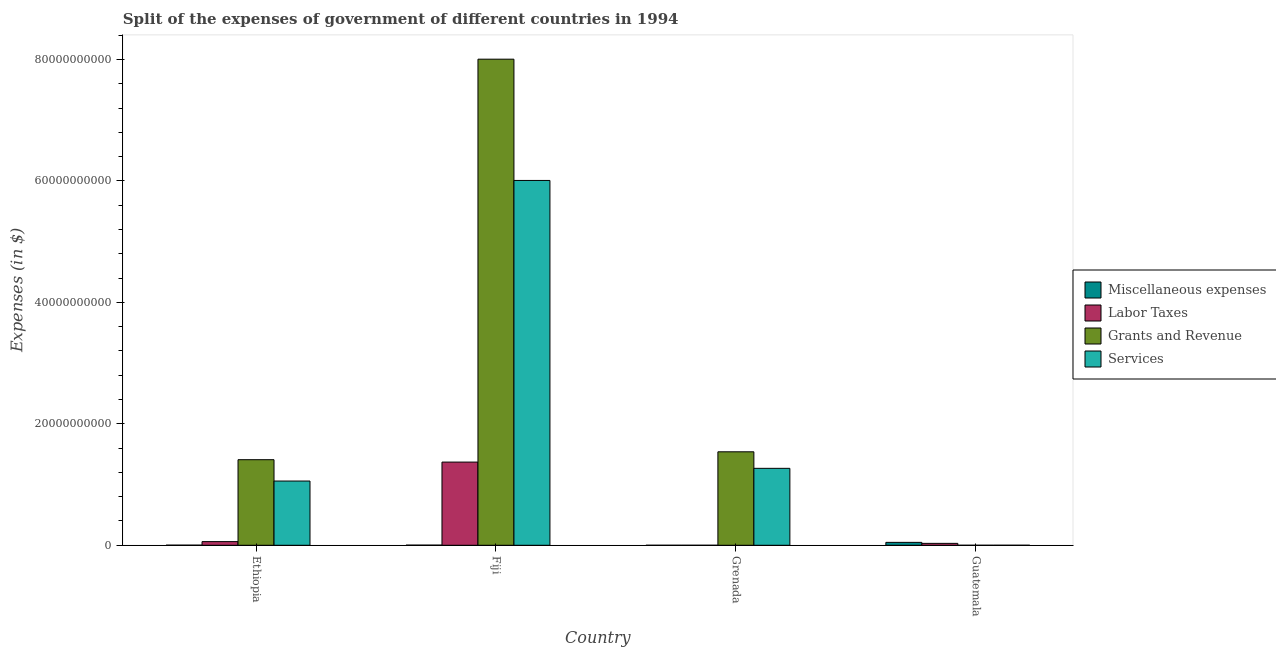Are the number of bars per tick equal to the number of legend labels?
Offer a terse response. Yes. How many bars are there on the 1st tick from the left?
Provide a succinct answer. 4. What is the label of the 1st group of bars from the left?
Provide a succinct answer. Ethiopia. What is the amount spent on grants and revenue in Fiji?
Offer a terse response. 8.00e+1. Across all countries, what is the maximum amount spent on grants and revenue?
Provide a short and direct response. 8.00e+1. Across all countries, what is the minimum amount spent on labor taxes?
Make the answer very short. 1.07e+05. In which country was the amount spent on labor taxes maximum?
Provide a short and direct response. Fiji. In which country was the amount spent on miscellaneous expenses minimum?
Provide a short and direct response. Grenada. What is the total amount spent on labor taxes in the graph?
Give a very brief answer. 1.46e+1. What is the difference between the amount spent on labor taxes in Fiji and that in Guatemala?
Your answer should be very brief. 1.34e+1. What is the difference between the amount spent on services in Ethiopia and the amount spent on miscellaneous expenses in Guatemala?
Make the answer very short. 1.01e+1. What is the average amount spent on grants and revenue per country?
Your answer should be very brief. 2.74e+1. What is the difference between the amount spent on miscellaneous expenses and amount spent on grants and revenue in Grenada?
Your response must be concise. -1.54e+1. In how many countries, is the amount spent on labor taxes greater than 8000000000 $?
Give a very brief answer. 1. What is the ratio of the amount spent on labor taxes in Ethiopia to that in Grenada?
Your response must be concise. 5616.09. Is the amount spent on services in Ethiopia less than that in Grenada?
Offer a terse response. Yes. What is the difference between the highest and the second highest amount spent on grants and revenue?
Offer a terse response. 6.47e+1. What is the difference between the highest and the lowest amount spent on services?
Provide a short and direct response. 6.01e+1. In how many countries, is the amount spent on miscellaneous expenses greater than the average amount spent on miscellaneous expenses taken over all countries?
Your response must be concise. 1. Is it the case that in every country, the sum of the amount spent on grants and revenue and amount spent on services is greater than the sum of amount spent on labor taxes and amount spent on miscellaneous expenses?
Ensure brevity in your answer.  No. What does the 4th bar from the left in Grenada represents?
Give a very brief answer. Services. What does the 1st bar from the right in Ethiopia represents?
Ensure brevity in your answer.  Services. Are all the bars in the graph horizontal?
Your answer should be compact. No. How many countries are there in the graph?
Your answer should be compact. 4. What is the difference between two consecutive major ticks on the Y-axis?
Make the answer very short. 2.00e+1. Are the values on the major ticks of Y-axis written in scientific E-notation?
Make the answer very short. No. Does the graph contain any zero values?
Provide a short and direct response. No. Does the graph contain grids?
Keep it short and to the point. No. How are the legend labels stacked?
Your answer should be very brief. Vertical. What is the title of the graph?
Offer a terse response. Split of the expenses of government of different countries in 1994. What is the label or title of the Y-axis?
Provide a short and direct response. Expenses (in $). What is the Expenses (in $) of Miscellaneous expenses in Ethiopia?
Your response must be concise. 1.81e+07. What is the Expenses (in $) of Labor Taxes in Ethiopia?
Your response must be concise. 6.03e+08. What is the Expenses (in $) in Grants and Revenue in Ethiopia?
Your answer should be very brief. 1.41e+1. What is the Expenses (in $) of Services in Ethiopia?
Offer a very short reply. 1.06e+1. What is the Expenses (in $) of Miscellaneous expenses in Fiji?
Make the answer very short. 2.37e+07. What is the Expenses (in $) of Labor Taxes in Fiji?
Make the answer very short. 1.37e+1. What is the Expenses (in $) in Grants and Revenue in Fiji?
Make the answer very short. 8.00e+1. What is the Expenses (in $) in Services in Fiji?
Give a very brief answer. 6.01e+1. What is the Expenses (in $) of Miscellaneous expenses in Grenada?
Give a very brief answer. 1.17e+06. What is the Expenses (in $) in Labor Taxes in Grenada?
Your response must be concise. 1.07e+05. What is the Expenses (in $) of Grants and Revenue in Grenada?
Provide a succinct answer. 1.54e+1. What is the Expenses (in $) of Services in Grenada?
Offer a very short reply. 1.27e+1. What is the Expenses (in $) of Miscellaneous expenses in Guatemala?
Provide a short and direct response. 4.79e+08. What is the Expenses (in $) of Labor Taxes in Guatemala?
Your response must be concise. 3.14e+08. What is the Expenses (in $) of Grants and Revenue in Guatemala?
Your answer should be very brief. 4.09e+05. What is the Expenses (in $) in Services in Guatemala?
Offer a very short reply. 1.49e+06. Across all countries, what is the maximum Expenses (in $) in Miscellaneous expenses?
Ensure brevity in your answer.  4.79e+08. Across all countries, what is the maximum Expenses (in $) in Labor Taxes?
Keep it short and to the point. 1.37e+1. Across all countries, what is the maximum Expenses (in $) in Grants and Revenue?
Offer a terse response. 8.00e+1. Across all countries, what is the maximum Expenses (in $) of Services?
Provide a succinct answer. 6.01e+1. Across all countries, what is the minimum Expenses (in $) of Miscellaneous expenses?
Your answer should be compact. 1.17e+06. Across all countries, what is the minimum Expenses (in $) of Labor Taxes?
Keep it short and to the point. 1.07e+05. Across all countries, what is the minimum Expenses (in $) in Grants and Revenue?
Keep it short and to the point. 4.09e+05. Across all countries, what is the minimum Expenses (in $) in Services?
Ensure brevity in your answer.  1.49e+06. What is the total Expenses (in $) of Miscellaneous expenses in the graph?
Keep it short and to the point. 5.22e+08. What is the total Expenses (in $) of Labor Taxes in the graph?
Provide a short and direct response. 1.46e+1. What is the total Expenses (in $) of Grants and Revenue in the graph?
Offer a very short reply. 1.10e+11. What is the total Expenses (in $) of Services in the graph?
Provide a succinct answer. 8.33e+1. What is the difference between the Expenses (in $) of Miscellaneous expenses in Ethiopia and that in Fiji?
Ensure brevity in your answer.  -5.62e+06. What is the difference between the Expenses (in $) in Labor Taxes in Ethiopia and that in Fiji?
Keep it short and to the point. -1.31e+1. What is the difference between the Expenses (in $) of Grants and Revenue in Ethiopia and that in Fiji?
Your answer should be very brief. -6.60e+1. What is the difference between the Expenses (in $) in Services in Ethiopia and that in Fiji?
Your answer should be compact. -4.95e+1. What is the difference between the Expenses (in $) of Miscellaneous expenses in Ethiopia and that in Grenada?
Offer a terse response. 1.69e+07. What is the difference between the Expenses (in $) in Labor Taxes in Ethiopia and that in Grenada?
Keep it short and to the point. 6.03e+08. What is the difference between the Expenses (in $) in Grants and Revenue in Ethiopia and that in Grenada?
Ensure brevity in your answer.  -1.30e+09. What is the difference between the Expenses (in $) of Services in Ethiopia and that in Grenada?
Offer a terse response. -2.09e+09. What is the difference between the Expenses (in $) in Miscellaneous expenses in Ethiopia and that in Guatemala?
Offer a terse response. -4.61e+08. What is the difference between the Expenses (in $) of Labor Taxes in Ethiopia and that in Guatemala?
Give a very brief answer. 2.89e+08. What is the difference between the Expenses (in $) of Grants and Revenue in Ethiopia and that in Guatemala?
Your answer should be compact. 1.41e+1. What is the difference between the Expenses (in $) of Services in Ethiopia and that in Guatemala?
Give a very brief answer. 1.06e+1. What is the difference between the Expenses (in $) of Miscellaneous expenses in Fiji and that in Grenada?
Your answer should be compact. 2.26e+07. What is the difference between the Expenses (in $) of Labor Taxes in Fiji and that in Grenada?
Keep it short and to the point. 1.37e+1. What is the difference between the Expenses (in $) in Grants and Revenue in Fiji and that in Grenada?
Offer a very short reply. 6.47e+1. What is the difference between the Expenses (in $) of Services in Fiji and that in Grenada?
Offer a terse response. 4.74e+1. What is the difference between the Expenses (in $) in Miscellaneous expenses in Fiji and that in Guatemala?
Provide a short and direct response. -4.55e+08. What is the difference between the Expenses (in $) in Labor Taxes in Fiji and that in Guatemala?
Give a very brief answer. 1.34e+1. What is the difference between the Expenses (in $) of Grants and Revenue in Fiji and that in Guatemala?
Offer a terse response. 8.00e+1. What is the difference between the Expenses (in $) in Services in Fiji and that in Guatemala?
Offer a terse response. 6.01e+1. What is the difference between the Expenses (in $) of Miscellaneous expenses in Grenada and that in Guatemala?
Your answer should be very brief. -4.78e+08. What is the difference between the Expenses (in $) in Labor Taxes in Grenada and that in Guatemala?
Ensure brevity in your answer.  -3.13e+08. What is the difference between the Expenses (in $) of Grants and Revenue in Grenada and that in Guatemala?
Your answer should be very brief. 1.54e+1. What is the difference between the Expenses (in $) of Services in Grenada and that in Guatemala?
Offer a terse response. 1.27e+1. What is the difference between the Expenses (in $) in Miscellaneous expenses in Ethiopia and the Expenses (in $) in Labor Taxes in Fiji?
Your response must be concise. -1.37e+1. What is the difference between the Expenses (in $) in Miscellaneous expenses in Ethiopia and the Expenses (in $) in Grants and Revenue in Fiji?
Give a very brief answer. -8.00e+1. What is the difference between the Expenses (in $) in Miscellaneous expenses in Ethiopia and the Expenses (in $) in Services in Fiji?
Offer a terse response. -6.01e+1. What is the difference between the Expenses (in $) of Labor Taxes in Ethiopia and the Expenses (in $) of Grants and Revenue in Fiji?
Keep it short and to the point. -7.94e+1. What is the difference between the Expenses (in $) in Labor Taxes in Ethiopia and the Expenses (in $) in Services in Fiji?
Provide a succinct answer. -5.95e+1. What is the difference between the Expenses (in $) of Grants and Revenue in Ethiopia and the Expenses (in $) of Services in Fiji?
Offer a terse response. -4.60e+1. What is the difference between the Expenses (in $) of Miscellaneous expenses in Ethiopia and the Expenses (in $) of Labor Taxes in Grenada?
Make the answer very short. 1.80e+07. What is the difference between the Expenses (in $) in Miscellaneous expenses in Ethiopia and the Expenses (in $) in Grants and Revenue in Grenada?
Provide a short and direct response. -1.54e+1. What is the difference between the Expenses (in $) of Miscellaneous expenses in Ethiopia and the Expenses (in $) of Services in Grenada?
Your response must be concise. -1.27e+1. What is the difference between the Expenses (in $) in Labor Taxes in Ethiopia and the Expenses (in $) in Grants and Revenue in Grenada?
Provide a short and direct response. -1.48e+1. What is the difference between the Expenses (in $) of Labor Taxes in Ethiopia and the Expenses (in $) of Services in Grenada?
Make the answer very short. -1.21e+1. What is the difference between the Expenses (in $) of Grants and Revenue in Ethiopia and the Expenses (in $) of Services in Grenada?
Make the answer very short. 1.42e+09. What is the difference between the Expenses (in $) in Miscellaneous expenses in Ethiopia and the Expenses (in $) in Labor Taxes in Guatemala?
Make the answer very short. -2.95e+08. What is the difference between the Expenses (in $) of Miscellaneous expenses in Ethiopia and the Expenses (in $) of Grants and Revenue in Guatemala?
Give a very brief answer. 1.77e+07. What is the difference between the Expenses (in $) in Miscellaneous expenses in Ethiopia and the Expenses (in $) in Services in Guatemala?
Keep it short and to the point. 1.66e+07. What is the difference between the Expenses (in $) of Labor Taxes in Ethiopia and the Expenses (in $) of Grants and Revenue in Guatemala?
Make the answer very short. 6.03e+08. What is the difference between the Expenses (in $) of Labor Taxes in Ethiopia and the Expenses (in $) of Services in Guatemala?
Ensure brevity in your answer.  6.02e+08. What is the difference between the Expenses (in $) in Grants and Revenue in Ethiopia and the Expenses (in $) in Services in Guatemala?
Offer a very short reply. 1.41e+1. What is the difference between the Expenses (in $) in Miscellaneous expenses in Fiji and the Expenses (in $) in Labor Taxes in Grenada?
Offer a terse response. 2.36e+07. What is the difference between the Expenses (in $) in Miscellaneous expenses in Fiji and the Expenses (in $) in Grants and Revenue in Grenada?
Provide a short and direct response. -1.54e+1. What is the difference between the Expenses (in $) of Miscellaneous expenses in Fiji and the Expenses (in $) of Services in Grenada?
Make the answer very short. -1.26e+1. What is the difference between the Expenses (in $) in Labor Taxes in Fiji and the Expenses (in $) in Grants and Revenue in Grenada?
Your response must be concise. -1.69e+09. What is the difference between the Expenses (in $) of Labor Taxes in Fiji and the Expenses (in $) of Services in Grenada?
Keep it short and to the point. 1.03e+09. What is the difference between the Expenses (in $) in Grants and Revenue in Fiji and the Expenses (in $) in Services in Grenada?
Your answer should be very brief. 6.74e+1. What is the difference between the Expenses (in $) of Miscellaneous expenses in Fiji and the Expenses (in $) of Labor Taxes in Guatemala?
Your answer should be compact. -2.90e+08. What is the difference between the Expenses (in $) of Miscellaneous expenses in Fiji and the Expenses (in $) of Grants and Revenue in Guatemala?
Make the answer very short. 2.33e+07. What is the difference between the Expenses (in $) of Miscellaneous expenses in Fiji and the Expenses (in $) of Services in Guatemala?
Give a very brief answer. 2.22e+07. What is the difference between the Expenses (in $) in Labor Taxes in Fiji and the Expenses (in $) in Grants and Revenue in Guatemala?
Ensure brevity in your answer.  1.37e+1. What is the difference between the Expenses (in $) in Labor Taxes in Fiji and the Expenses (in $) in Services in Guatemala?
Provide a succinct answer. 1.37e+1. What is the difference between the Expenses (in $) of Grants and Revenue in Fiji and the Expenses (in $) of Services in Guatemala?
Make the answer very short. 8.00e+1. What is the difference between the Expenses (in $) of Miscellaneous expenses in Grenada and the Expenses (in $) of Labor Taxes in Guatemala?
Your answer should be compact. -3.12e+08. What is the difference between the Expenses (in $) in Miscellaneous expenses in Grenada and the Expenses (in $) in Grants and Revenue in Guatemala?
Ensure brevity in your answer.  7.61e+05. What is the difference between the Expenses (in $) in Miscellaneous expenses in Grenada and the Expenses (in $) in Services in Guatemala?
Provide a short and direct response. -3.23e+05. What is the difference between the Expenses (in $) of Labor Taxes in Grenada and the Expenses (in $) of Grants and Revenue in Guatemala?
Your response must be concise. -3.02e+05. What is the difference between the Expenses (in $) of Labor Taxes in Grenada and the Expenses (in $) of Services in Guatemala?
Provide a succinct answer. -1.39e+06. What is the difference between the Expenses (in $) in Grants and Revenue in Grenada and the Expenses (in $) in Services in Guatemala?
Make the answer very short. 1.54e+1. What is the average Expenses (in $) in Miscellaneous expenses per country?
Give a very brief answer. 1.31e+08. What is the average Expenses (in $) in Labor Taxes per country?
Offer a terse response. 3.65e+09. What is the average Expenses (in $) of Grants and Revenue per country?
Your answer should be compact. 2.74e+1. What is the average Expenses (in $) of Services per country?
Provide a succinct answer. 2.08e+1. What is the difference between the Expenses (in $) in Miscellaneous expenses and Expenses (in $) in Labor Taxes in Ethiopia?
Provide a short and direct response. -5.85e+08. What is the difference between the Expenses (in $) of Miscellaneous expenses and Expenses (in $) of Grants and Revenue in Ethiopia?
Provide a short and direct response. -1.41e+1. What is the difference between the Expenses (in $) of Miscellaneous expenses and Expenses (in $) of Services in Ethiopia?
Make the answer very short. -1.06e+1. What is the difference between the Expenses (in $) of Labor Taxes and Expenses (in $) of Grants and Revenue in Ethiopia?
Your answer should be compact. -1.35e+1. What is the difference between the Expenses (in $) of Labor Taxes and Expenses (in $) of Services in Ethiopia?
Make the answer very short. -9.97e+09. What is the difference between the Expenses (in $) of Grants and Revenue and Expenses (in $) of Services in Ethiopia?
Provide a short and direct response. 3.52e+09. What is the difference between the Expenses (in $) of Miscellaneous expenses and Expenses (in $) of Labor Taxes in Fiji?
Offer a very short reply. -1.37e+1. What is the difference between the Expenses (in $) in Miscellaneous expenses and Expenses (in $) in Grants and Revenue in Fiji?
Ensure brevity in your answer.  -8.00e+1. What is the difference between the Expenses (in $) in Miscellaneous expenses and Expenses (in $) in Services in Fiji?
Ensure brevity in your answer.  -6.01e+1. What is the difference between the Expenses (in $) in Labor Taxes and Expenses (in $) in Grants and Revenue in Fiji?
Provide a short and direct response. -6.64e+1. What is the difference between the Expenses (in $) in Labor Taxes and Expenses (in $) in Services in Fiji?
Provide a short and direct response. -4.64e+1. What is the difference between the Expenses (in $) of Grants and Revenue and Expenses (in $) of Services in Fiji?
Your answer should be compact. 2.00e+1. What is the difference between the Expenses (in $) of Miscellaneous expenses and Expenses (in $) of Labor Taxes in Grenada?
Give a very brief answer. 1.06e+06. What is the difference between the Expenses (in $) of Miscellaneous expenses and Expenses (in $) of Grants and Revenue in Grenada?
Your answer should be compact. -1.54e+1. What is the difference between the Expenses (in $) of Miscellaneous expenses and Expenses (in $) of Services in Grenada?
Your response must be concise. -1.27e+1. What is the difference between the Expenses (in $) of Labor Taxes and Expenses (in $) of Grants and Revenue in Grenada?
Keep it short and to the point. -1.54e+1. What is the difference between the Expenses (in $) in Labor Taxes and Expenses (in $) in Services in Grenada?
Provide a succinct answer. -1.27e+1. What is the difference between the Expenses (in $) in Grants and Revenue and Expenses (in $) in Services in Grenada?
Your answer should be very brief. 2.72e+09. What is the difference between the Expenses (in $) in Miscellaneous expenses and Expenses (in $) in Labor Taxes in Guatemala?
Your response must be concise. 1.66e+08. What is the difference between the Expenses (in $) of Miscellaneous expenses and Expenses (in $) of Grants and Revenue in Guatemala?
Ensure brevity in your answer.  4.79e+08. What is the difference between the Expenses (in $) of Miscellaneous expenses and Expenses (in $) of Services in Guatemala?
Offer a terse response. 4.78e+08. What is the difference between the Expenses (in $) of Labor Taxes and Expenses (in $) of Grants and Revenue in Guatemala?
Ensure brevity in your answer.  3.13e+08. What is the difference between the Expenses (in $) of Labor Taxes and Expenses (in $) of Services in Guatemala?
Make the answer very short. 3.12e+08. What is the difference between the Expenses (in $) in Grants and Revenue and Expenses (in $) in Services in Guatemala?
Provide a succinct answer. -1.08e+06. What is the ratio of the Expenses (in $) of Miscellaneous expenses in Ethiopia to that in Fiji?
Keep it short and to the point. 0.76. What is the ratio of the Expenses (in $) in Labor Taxes in Ethiopia to that in Fiji?
Your answer should be very brief. 0.04. What is the ratio of the Expenses (in $) of Grants and Revenue in Ethiopia to that in Fiji?
Keep it short and to the point. 0.18. What is the ratio of the Expenses (in $) in Services in Ethiopia to that in Fiji?
Make the answer very short. 0.18. What is the ratio of the Expenses (in $) in Miscellaneous expenses in Ethiopia to that in Grenada?
Your answer should be very brief. 15.47. What is the ratio of the Expenses (in $) of Labor Taxes in Ethiopia to that in Grenada?
Give a very brief answer. 5616.09. What is the ratio of the Expenses (in $) of Grants and Revenue in Ethiopia to that in Grenada?
Offer a very short reply. 0.92. What is the ratio of the Expenses (in $) of Services in Ethiopia to that in Grenada?
Your response must be concise. 0.83. What is the ratio of the Expenses (in $) in Miscellaneous expenses in Ethiopia to that in Guatemala?
Make the answer very short. 0.04. What is the ratio of the Expenses (in $) of Labor Taxes in Ethiopia to that in Guatemala?
Offer a very short reply. 1.92. What is the ratio of the Expenses (in $) of Grants and Revenue in Ethiopia to that in Guatemala?
Your response must be concise. 3.44e+04. What is the ratio of the Expenses (in $) of Services in Ethiopia to that in Guatemala?
Offer a very short reply. 7085.96. What is the ratio of the Expenses (in $) of Miscellaneous expenses in Fiji to that in Grenada?
Provide a short and direct response. 20.27. What is the ratio of the Expenses (in $) of Labor Taxes in Fiji to that in Grenada?
Offer a terse response. 1.28e+05. What is the ratio of the Expenses (in $) in Grants and Revenue in Fiji to that in Grenada?
Provide a short and direct response. 5.2. What is the ratio of the Expenses (in $) of Services in Fiji to that in Grenada?
Offer a terse response. 4.74. What is the ratio of the Expenses (in $) of Miscellaneous expenses in Fiji to that in Guatemala?
Offer a terse response. 0.05. What is the ratio of the Expenses (in $) of Labor Taxes in Fiji to that in Guatemala?
Keep it short and to the point. 43.69. What is the ratio of the Expenses (in $) of Grants and Revenue in Fiji to that in Guatemala?
Your answer should be very brief. 1.96e+05. What is the ratio of the Expenses (in $) of Services in Fiji to that in Guatemala?
Your answer should be very brief. 4.03e+04. What is the ratio of the Expenses (in $) of Miscellaneous expenses in Grenada to that in Guatemala?
Ensure brevity in your answer.  0. What is the ratio of the Expenses (in $) of Labor Taxes in Grenada to that in Guatemala?
Offer a terse response. 0. What is the ratio of the Expenses (in $) of Grants and Revenue in Grenada to that in Guatemala?
Provide a succinct answer. 3.76e+04. What is the ratio of the Expenses (in $) of Services in Grenada to that in Guatemala?
Provide a short and direct response. 8488.82. What is the difference between the highest and the second highest Expenses (in $) in Miscellaneous expenses?
Make the answer very short. 4.55e+08. What is the difference between the highest and the second highest Expenses (in $) of Labor Taxes?
Give a very brief answer. 1.31e+1. What is the difference between the highest and the second highest Expenses (in $) of Grants and Revenue?
Ensure brevity in your answer.  6.47e+1. What is the difference between the highest and the second highest Expenses (in $) of Services?
Make the answer very short. 4.74e+1. What is the difference between the highest and the lowest Expenses (in $) in Miscellaneous expenses?
Your answer should be compact. 4.78e+08. What is the difference between the highest and the lowest Expenses (in $) in Labor Taxes?
Your response must be concise. 1.37e+1. What is the difference between the highest and the lowest Expenses (in $) of Grants and Revenue?
Offer a terse response. 8.00e+1. What is the difference between the highest and the lowest Expenses (in $) of Services?
Make the answer very short. 6.01e+1. 